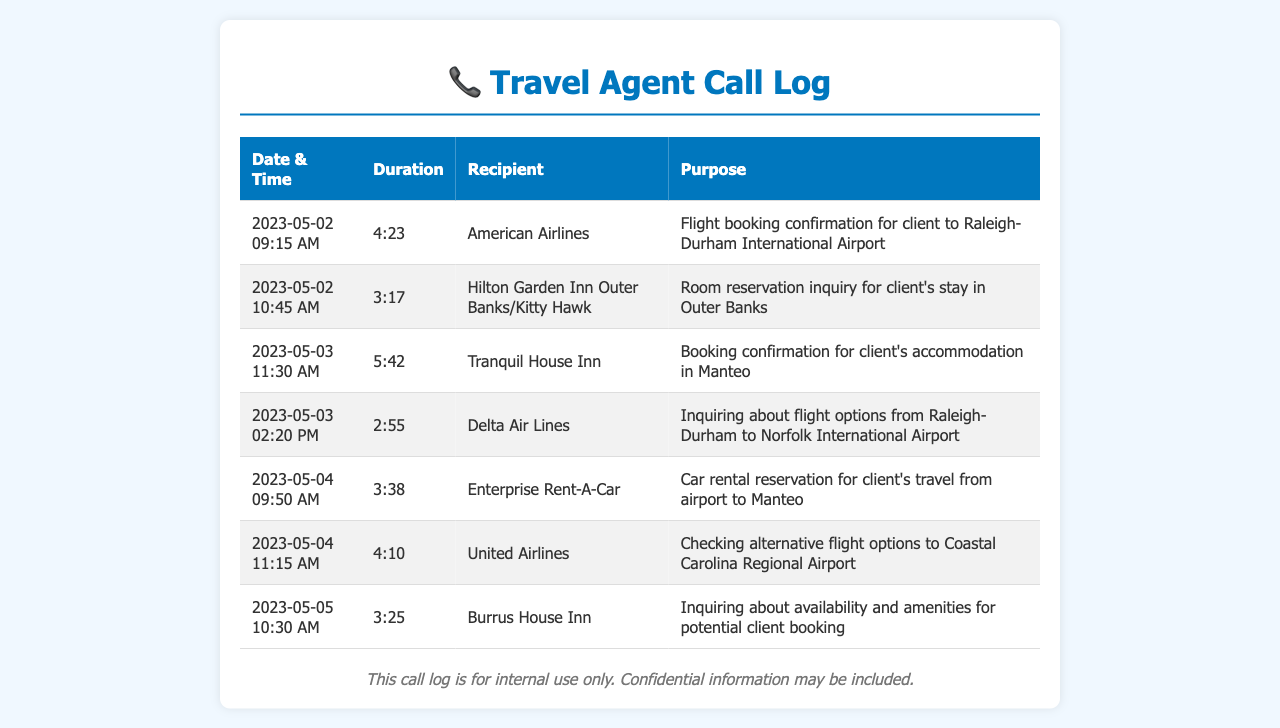What was the purpose of the call to American Airlines? The purpose was to confirm a flight booking for a client to Raleigh-Durham International Airport.
Answer: Flight booking confirmation for client to Raleigh-Durham International Airport How long was the call to Hilton Garden Inn Outer Banks/Kitty Hawk? The duration of that call was indicated in the document, which shows the time spent on the call.
Answer: 3:17 When was the booking confirmation call made to Tranquil House Inn? The document lists the date and time of each call, including the booking confirmation call.
Answer: 2023-05-03 11:30 AM Which hotel was contacted on May 5th, and what was discussed? The document contains details about each call, including the hotel's name and the purpose of the conversation.
Answer: Burrus House Inn; availability and amenities for potential client booking What was the duration of the call to Enterprise Rent-A-Car? The document provides specific information about the duration of each call made.
Answer: 3:38 What type of call was made to Delta Air Lines? The document categorizes the calls and identifies their purposes, showing the inquiry nature of this call.
Answer: Inquiring about flight options from Raleigh-Durham to Norfolk International Airport How many calls were made to airlines in total? By counting the entries related to airlines, you can determine the number of calls made.
Answer: 4 